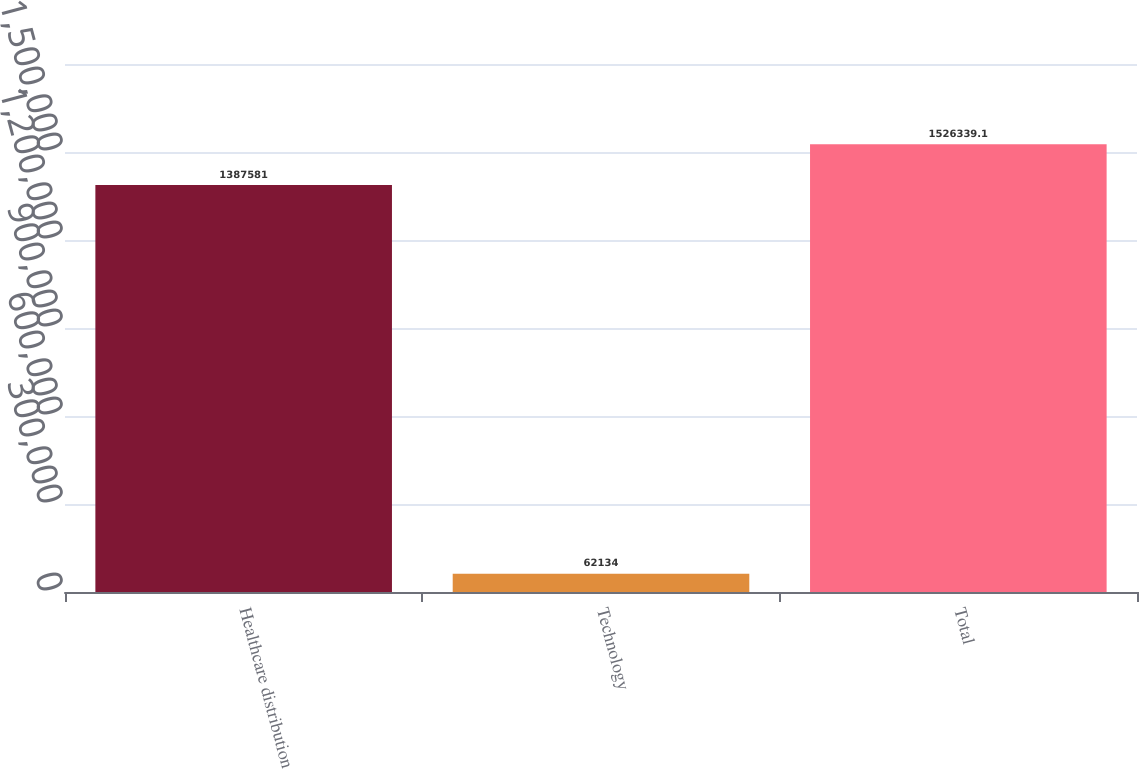Convert chart to OTSL. <chart><loc_0><loc_0><loc_500><loc_500><bar_chart><fcel>Healthcare distribution<fcel>Technology<fcel>Total<nl><fcel>1.38758e+06<fcel>62134<fcel>1.52634e+06<nl></chart> 